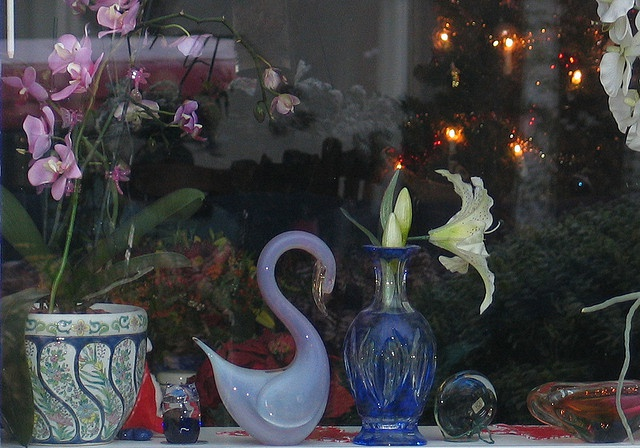Describe the objects in this image and their specific colors. I can see potted plant in darkblue, black, gray, and darkgray tones, vase in darkblue, gray, darkgray, and blue tones, potted plant in darkblue, black, maroon, gray, and darkgreen tones, and vase in darkblue, navy, black, and gray tones in this image. 